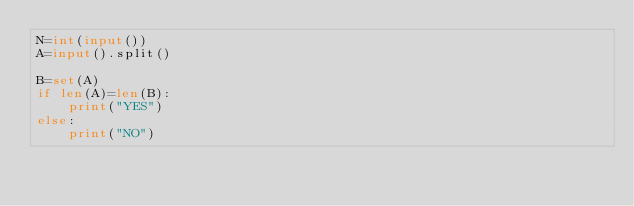<code> <loc_0><loc_0><loc_500><loc_500><_Python_>N=int(input())
A=input().split()

B=set(A)
if len(A)=len(B):
    print("YES")
else:
    print("NO")</code> 